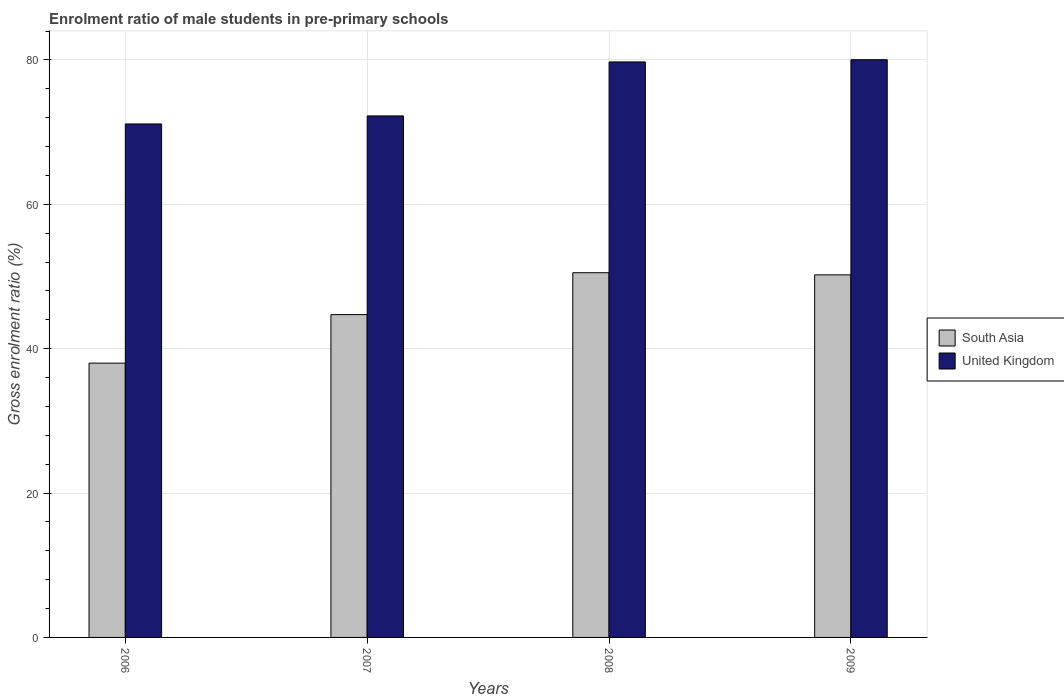How many different coloured bars are there?
Your response must be concise. 2. How many groups of bars are there?
Your response must be concise. 4. How many bars are there on the 3rd tick from the left?
Ensure brevity in your answer.  2. How many bars are there on the 3rd tick from the right?
Give a very brief answer. 2. What is the enrolment ratio of male students in pre-primary schools in South Asia in 2009?
Ensure brevity in your answer.  50.23. Across all years, what is the maximum enrolment ratio of male students in pre-primary schools in South Asia?
Offer a terse response. 50.52. Across all years, what is the minimum enrolment ratio of male students in pre-primary schools in United Kingdom?
Provide a short and direct response. 71.13. In which year was the enrolment ratio of male students in pre-primary schools in United Kingdom minimum?
Provide a succinct answer. 2006. What is the total enrolment ratio of male students in pre-primary schools in United Kingdom in the graph?
Give a very brief answer. 303.13. What is the difference between the enrolment ratio of male students in pre-primary schools in United Kingdom in 2008 and that in 2009?
Give a very brief answer. -0.31. What is the difference between the enrolment ratio of male students in pre-primary schools in United Kingdom in 2007 and the enrolment ratio of male students in pre-primary schools in South Asia in 2008?
Keep it short and to the point. 21.72. What is the average enrolment ratio of male students in pre-primary schools in United Kingdom per year?
Provide a succinct answer. 75.78. In the year 2009, what is the difference between the enrolment ratio of male students in pre-primary schools in United Kingdom and enrolment ratio of male students in pre-primary schools in South Asia?
Make the answer very short. 29.8. In how many years, is the enrolment ratio of male students in pre-primary schools in United Kingdom greater than 28 %?
Your response must be concise. 4. What is the ratio of the enrolment ratio of male students in pre-primary schools in South Asia in 2007 to that in 2008?
Keep it short and to the point. 0.89. What is the difference between the highest and the second highest enrolment ratio of male students in pre-primary schools in South Asia?
Give a very brief answer. 0.3. What is the difference between the highest and the lowest enrolment ratio of male students in pre-primary schools in South Asia?
Provide a succinct answer. 12.53. Is the sum of the enrolment ratio of male students in pre-primary schools in South Asia in 2006 and 2008 greater than the maximum enrolment ratio of male students in pre-primary schools in United Kingdom across all years?
Make the answer very short. Yes. What does the 2nd bar from the right in 2008 represents?
Give a very brief answer. South Asia. How many bars are there?
Give a very brief answer. 8. Are all the bars in the graph horizontal?
Keep it short and to the point. No. How many years are there in the graph?
Provide a succinct answer. 4. Does the graph contain any zero values?
Keep it short and to the point. No. Does the graph contain grids?
Your response must be concise. Yes. What is the title of the graph?
Provide a succinct answer. Enrolment ratio of male students in pre-primary schools. What is the label or title of the X-axis?
Ensure brevity in your answer.  Years. What is the Gross enrolment ratio (%) of South Asia in 2006?
Give a very brief answer. 38. What is the Gross enrolment ratio (%) in United Kingdom in 2006?
Your answer should be compact. 71.13. What is the Gross enrolment ratio (%) in South Asia in 2007?
Provide a short and direct response. 44.72. What is the Gross enrolment ratio (%) in United Kingdom in 2007?
Give a very brief answer. 72.25. What is the Gross enrolment ratio (%) in South Asia in 2008?
Make the answer very short. 50.52. What is the Gross enrolment ratio (%) of United Kingdom in 2008?
Make the answer very short. 79.72. What is the Gross enrolment ratio (%) of South Asia in 2009?
Your response must be concise. 50.23. What is the Gross enrolment ratio (%) in United Kingdom in 2009?
Ensure brevity in your answer.  80.03. Across all years, what is the maximum Gross enrolment ratio (%) of South Asia?
Your answer should be very brief. 50.52. Across all years, what is the maximum Gross enrolment ratio (%) of United Kingdom?
Your answer should be very brief. 80.03. Across all years, what is the minimum Gross enrolment ratio (%) of South Asia?
Your answer should be compact. 38. Across all years, what is the minimum Gross enrolment ratio (%) of United Kingdom?
Your response must be concise. 71.13. What is the total Gross enrolment ratio (%) in South Asia in the graph?
Make the answer very short. 183.47. What is the total Gross enrolment ratio (%) in United Kingdom in the graph?
Offer a very short reply. 303.13. What is the difference between the Gross enrolment ratio (%) in South Asia in 2006 and that in 2007?
Give a very brief answer. -6.72. What is the difference between the Gross enrolment ratio (%) in United Kingdom in 2006 and that in 2007?
Offer a very short reply. -1.11. What is the difference between the Gross enrolment ratio (%) of South Asia in 2006 and that in 2008?
Keep it short and to the point. -12.53. What is the difference between the Gross enrolment ratio (%) of United Kingdom in 2006 and that in 2008?
Ensure brevity in your answer.  -8.59. What is the difference between the Gross enrolment ratio (%) of South Asia in 2006 and that in 2009?
Offer a very short reply. -12.23. What is the difference between the Gross enrolment ratio (%) of United Kingdom in 2006 and that in 2009?
Make the answer very short. -8.9. What is the difference between the Gross enrolment ratio (%) of South Asia in 2007 and that in 2008?
Your answer should be compact. -5.81. What is the difference between the Gross enrolment ratio (%) of United Kingdom in 2007 and that in 2008?
Your answer should be compact. -7.48. What is the difference between the Gross enrolment ratio (%) of South Asia in 2007 and that in 2009?
Provide a short and direct response. -5.51. What is the difference between the Gross enrolment ratio (%) in United Kingdom in 2007 and that in 2009?
Your answer should be compact. -7.79. What is the difference between the Gross enrolment ratio (%) in South Asia in 2008 and that in 2009?
Ensure brevity in your answer.  0.3. What is the difference between the Gross enrolment ratio (%) of United Kingdom in 2008 and that in 2009?
Provide a short and direct response. -0.31. What is the difference between the Gross enrolment ratio (%) of South Asia in 2006 and the Gross enrolment ratio (%) of United Kingdom in 2007?
Your response must be concise. -34.25. What is the difference between the Gross enrolment ratio (%) of South Asia in 2006 and the Gross enrolment ratio (%) of United Kingdom in 2008?
Offer a very short reply. -41.72. What is the difference between the Gross enrolment ratio (%) in South Asia in 2006 and the Gross enrolment ratio (%) in United Kingdom in 2009?
Your answer should be very brief. -42.03. What is the difference between the Gross enrolment ratio (%) in South Asia in 2007 and the Gross enrolment ratio (%) in United Kingdom in 2008?
Your answer should be compact. -35. What is the difference between the Gross enrolment ratio (%) of South Asia in 2007 and the Gross enrolment ratio (%) of United Kingdom in 2009?
Provide a succinct answer. -35.31. What is the difference between the Gross enrolment ratio (%) in South Asia in 2008 and the Gross enrolment ratio (%) in United Kingdom in 2009?
Your answer should be compact. -29.51. What is the average Gross enrolment ratio (%) in South Asia per year?
Your answer should be very brief. 45.87. What is the average Gross enrolment ratio (%) in United Kingdom per year?
Offer a terse response. 75.78. In the year 2006, what is the difference between the Gross enrolment ratio (%) in South Asia and Gross enrolment ratio (%) in United Kingdom?
Offer a very short reply. -33.13. In the year 2007, what is the difference between the Gross enrolment ratio (%) of South Asia and Gross enrolment ratio (%) of United Kingdom?
Ensure brevity in your answer.  -27.53. In the year 2008, what is the difference between the Gross enrolment ratio (%) of South Asia and Gross enrolment ratio (%) of United Kingdom?
Your answer should be compact. -29.2. In the year 2009, what is the difference between the Gross enrolment ratio (%) of South Asia and Gross enrolment ratio (%) of United Kingdom?
Offer a very short reply. -29.8. What is the ratio of the Gross enrolment ratio (%) of South Asia in 2006 to that in 2007?
Keep it short and to the point. 0.85. What is the ratio of the Gross enrolment ratio (%) in United Kingdom in 2006 to that in 2007?
Your answer should be very brief. 0.98. What is the ratio of the Gross enrolment ratio (%) of South Asia in 2006 to that in 2008?
Ensure brevity in your answer.  0.75. What is the ratio of the Gross enrolment ratio (%) in United Kingdom in 2006 to that in 2008?
Ensure brevity in your answer.  0.89. What is the ratio of the Gross enrolment ratio (%) of South Asia in 2006 to that in 2009?
Offer a terse response. 0.76. What is the ratio of the Gross enrolment ratio (%) of United Kingdom in 2006 to that in 2009?
Offer a terse response. 0.89. What is the ratio of the Gross enrolment ratio (%) in South Asia in 2007 to that in 2008?
Your answer should be compact. 0.89. What is the ratio of the Gross enrolment ratio (%) in United Kingdom in 2007 to that in 2008?
Provide a short and direct response. 0.91. What is the ratio of the Gross enrolment ratio (%) of South Asia in 2007 to that in 2009?
Your answer should be very brief. 0.89. What is the ratio of the Gross enrolment ratio (%) of United Kingdom in 2007 to that in 2009?
Offer a very short reply. 0.9. What is the ratio of the Gross enrolment ratio (%) in South Asia in 2008 to that in 2009?
Keep it short and to the point. 1.01. What is the difference between the highest and the second highest Gross enrolment ratio (%) of South Asia?
Your response must be concise. 0.3. What is the difference between the highest and the second highest Gross enrolment ratio (%) in United Kingdom?
Provide a short and direct response. 0.31. What is the difference between the highest and the lowest Gross enrolment ratio (%) of South Asia?
Your answer should be very brief. 12.53. What is the difference between the highest and the lowest Gross enrolment ratio (%) of United Kingdom?
Offer a terse response. 8.9. 